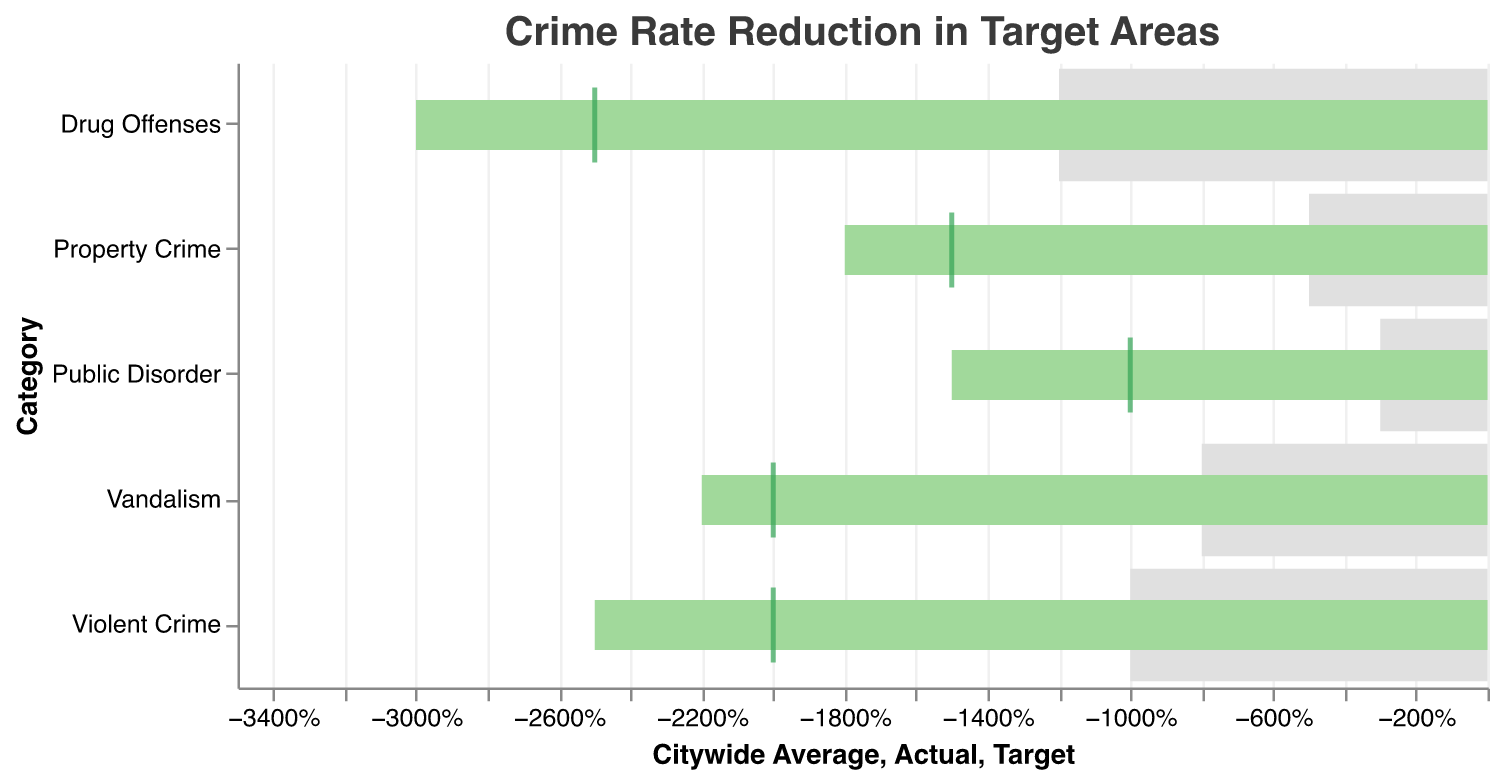What's the title of the figure? The title of a figure is usually found at the top, summarizing the main content. Here, it's clearly written at the top.
Answer: Crime Rate Reduction in Target Areas What is the actual reduction percentage for Violent Crime? Referring to the bar labeled "Violent Crime" in the "Actual" field, this value represents the actual reduction.
Answer: -25% Which crime category shows the largest difference between the actual reduction and the citywide average? Calculate the differences for each category and compare: -25% - (-10%) = -15%, -18% - (-5%) = -13%, -30% - (-12%) = -18%, -22% - (-8%) = -14%, -15% - (-3%) = -12%. Drug Offenses have the largest difference.
Answer: Drug Offenses How many crime categories meet or exceed their target reduction goals? We need to compare the "Actual" reduction against the "Target" for each category. If the actual value is less than or equal to the target, the goal is met: Violent Crime (-25% <= -20%), Property Crime (-18% <= -15%), Drug Offenses (-30% <= -25%), Vandalism (-22% <= -20%), Public Disorder (-15% <= -10%).
Answer: All 5 categories Which crime category has the smallest actual reduction percentage? Look at all the actual reduction percentages and identify the smallest number: -25%, -18%, -30%, -22%, -15%. The smallest is -15%.
Answer: Public Disorder What is the target reduction percentage for Property Crime? Referring to the tick mark in the bar labeled "Property Crime," this value represents the target reduction.
Answer: -15% How do the reductions in Violent Crime and Vandalism compare against their citywide averages? Compare -25% vs. -10% for Violent Crime and -22% vs. -8% for Vandalism. Both actual figures are further from zero compared to their citywide averages, indicating better performance in the targeted areas.
Answer: Both are significantly lower than their citywide averages Which crime category shows the smallest difference between the actual reduction and the target reduction? Calculate differences between actual and target reductions: Violent Crime (-25% - -20% = -5%), Property Crime (-18% - -15% = -3%), Drug Offenses (-30% - -25% = -5%), Vandalism (-22% - -20% = -2%), Public Disorder (-15% - -10% = -5%). Vandalism has the smallest difference.
Answer: Vandalism How does the actual reduction in Drug Offenses compare to the target reduction? Compare -30% (actual) with -25% (target). Since -30% is less than -25%, the actual reduction is greater (more negative) than the target.
Answer: Greater reduction than target What conclusion can be drawn about the reduction in Public Disorder compared to the citywide average and the target? First, compare the actual reduction -15% against the citywide average -3% and the target -10%. The actual reduction is more significant than both the citywide average and the target, showing effectiveness in the target area.
Answer: More significant reduction than both citywide average and target 